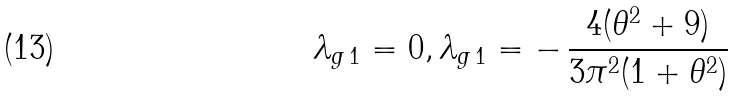Convert formula to latex. <formula><loc_0><loc_0><loc_500><loc_500>\lambda _ { g \, 1 } = 0 , \lambda _ { g \, 1 } = - \, \frac { 4 ( \theta ^ { 2 } + 9 ) } { 3 \pi ^ { 2 } ( 1 + \theta ^ { 2 } ) }</formula> 